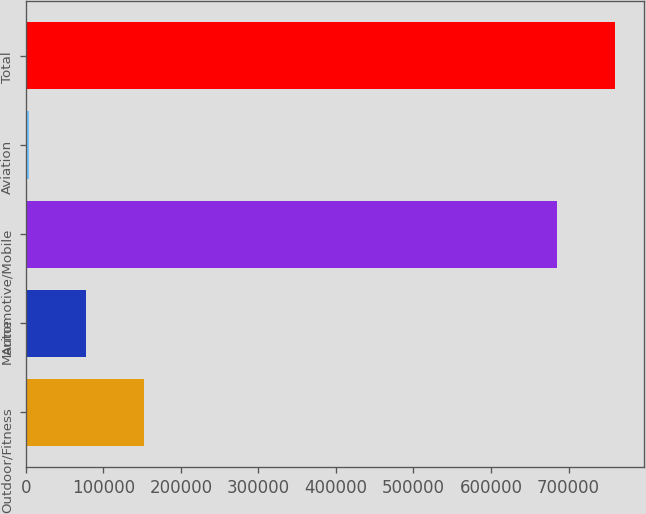Convert chart. <chart><loc_0><loc_0><loc_500><loc_500><bar_chart><fcel>Outdoor/Fitness<fcel>Marine<fcel>Automotive/Mobile<fcel>Aviation<fcel>Total<nl><fcel>152244<fcel>77995.9<fcel>685676<fcel>3748<fcel>759924<nl></chart> 